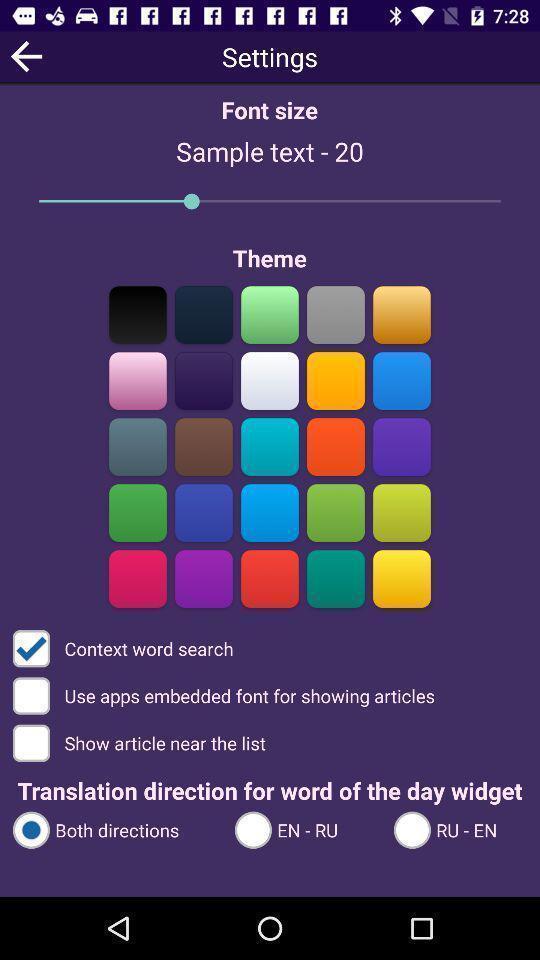Tell me what you see in this picture. Setting page for setting keyboard. 